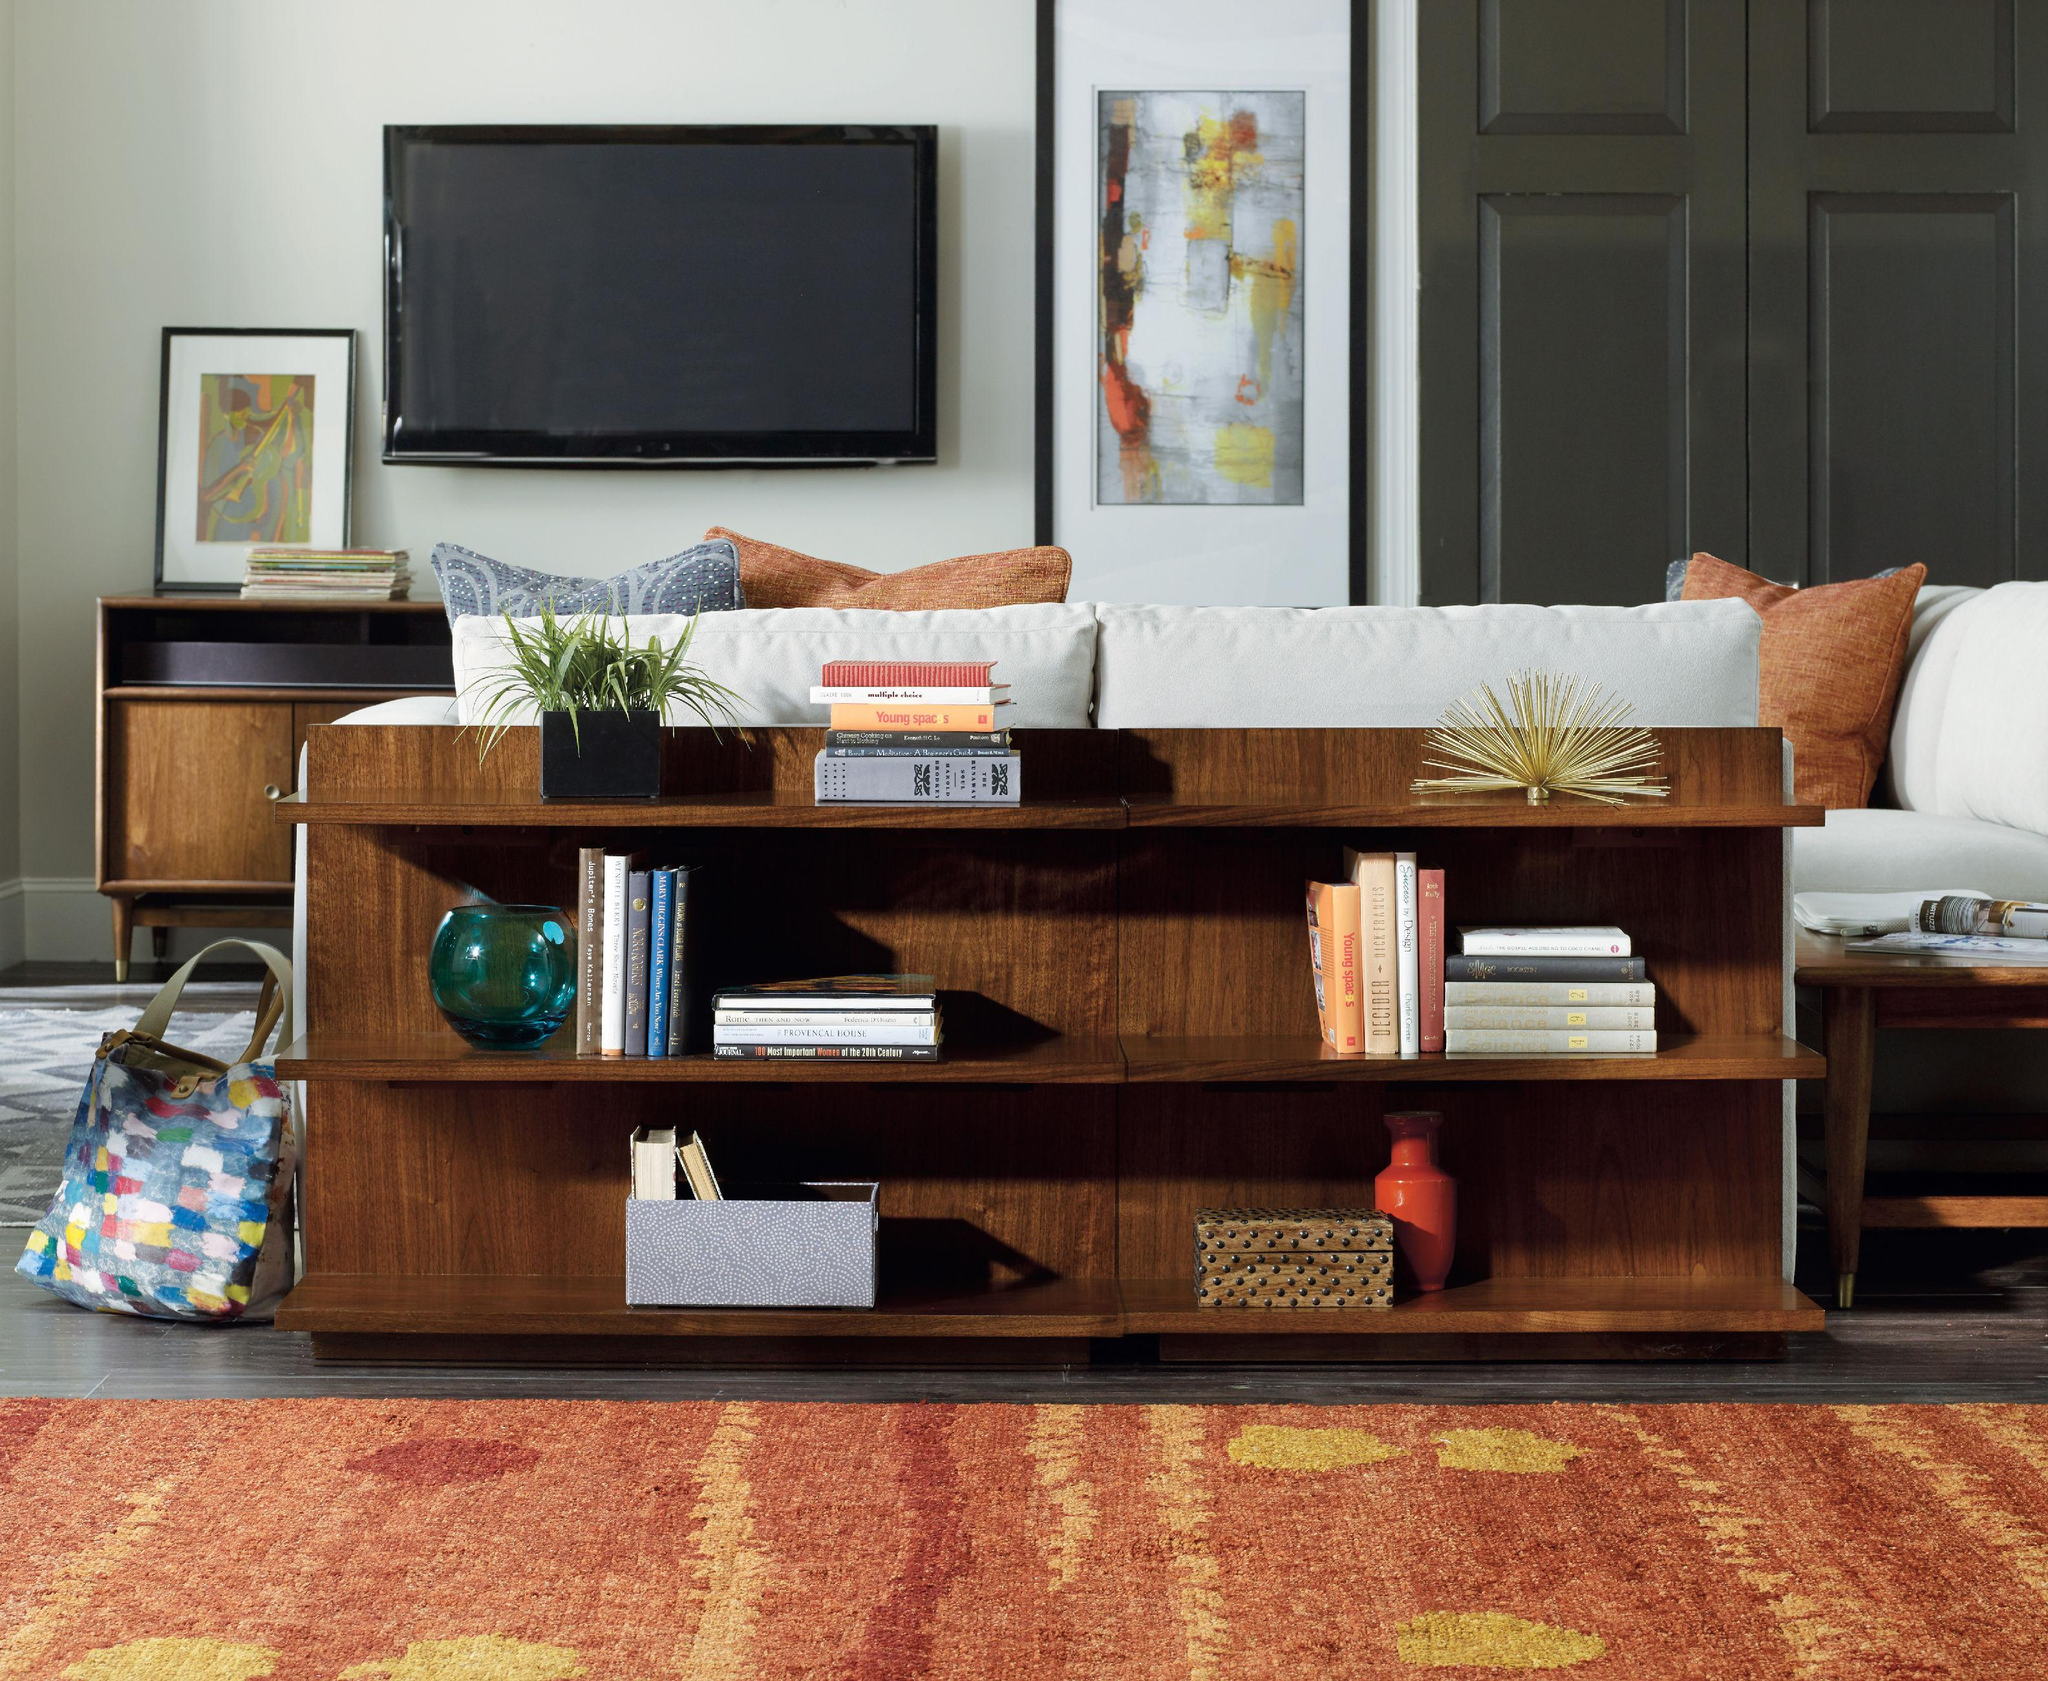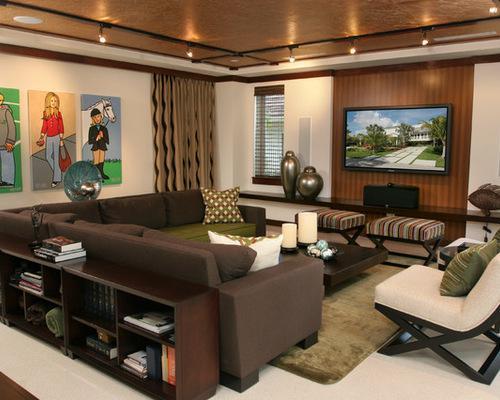The first image is the image on the left, the second image is the image on the right. Analyze the images presented: Is the assertion "There is a 4 cubby bookshelf up against a sofa back with books in the shelf" valid? Answer yes or no. No. The first image is the image on the left, the second image is the image on the right. Considering the images on both sides, is "In the right image the bookshelf has four different shelves with the bottom left shelf being empty." valid? Answer yes or no. No. 